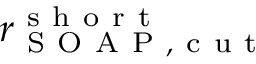<formula> <loc_0><loc_0><loc_500><loc_500>r _ { S O A P , c u t } ^ { s h o r t }</formula> 